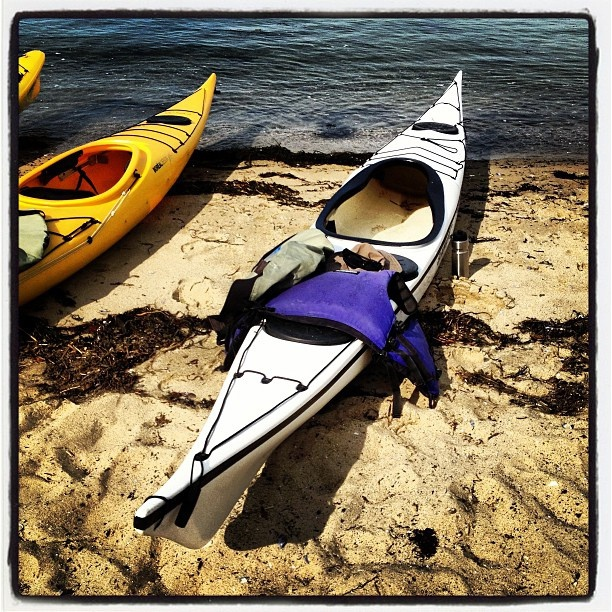Describe the objects in this image and their specific colors. I can see boat in white, black, gray, and tan tones, boat in white, black, gold, red, and maroon tones, and boat in white, gold, black, and orange tones in this image. 